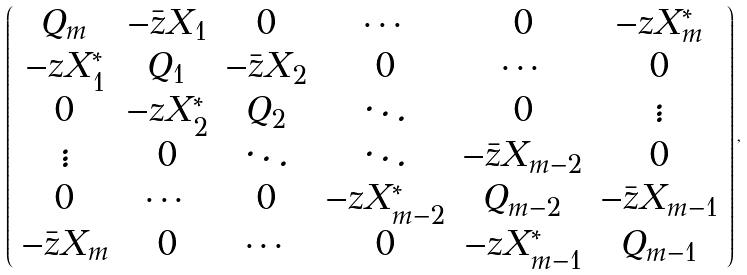<formula> <loc_0><loc_0><loc_500><loc_500>\left ( \begin{array} { c c c c c c } Q _ { m } & - \bar { z } X _ { 1 } & 0 & \cdots & 0 & - z X _ { m } ^ { \ast } \\ - z X _ { 1 } ^ { \ast } & Q _ { 1 } & - \bar { z } X _ { 2 } & 0 & \cdots & 0 \\ 0 & - z X _ { 2 } ^ { \ast } & Q _ { 2 } & \ddots & 0 & \vdots \\ \vdots & 0 & \ddots & \ddots & - \bar { z } X _ { m - 2 } & 0 \\ 0 & \cdots & 0 & - z X _ { m - 2 } ^ { \ast } & Q _ { m - 2 } & - \bar { z } X _ { m - 1 } \\ - \bar { z } X _ { m } & 0 & \cdots & 0 & - z X _ { m - 1 } ^ { \ast } & Q _ { m - 1 } \end{array} \right ) ,</formula> 